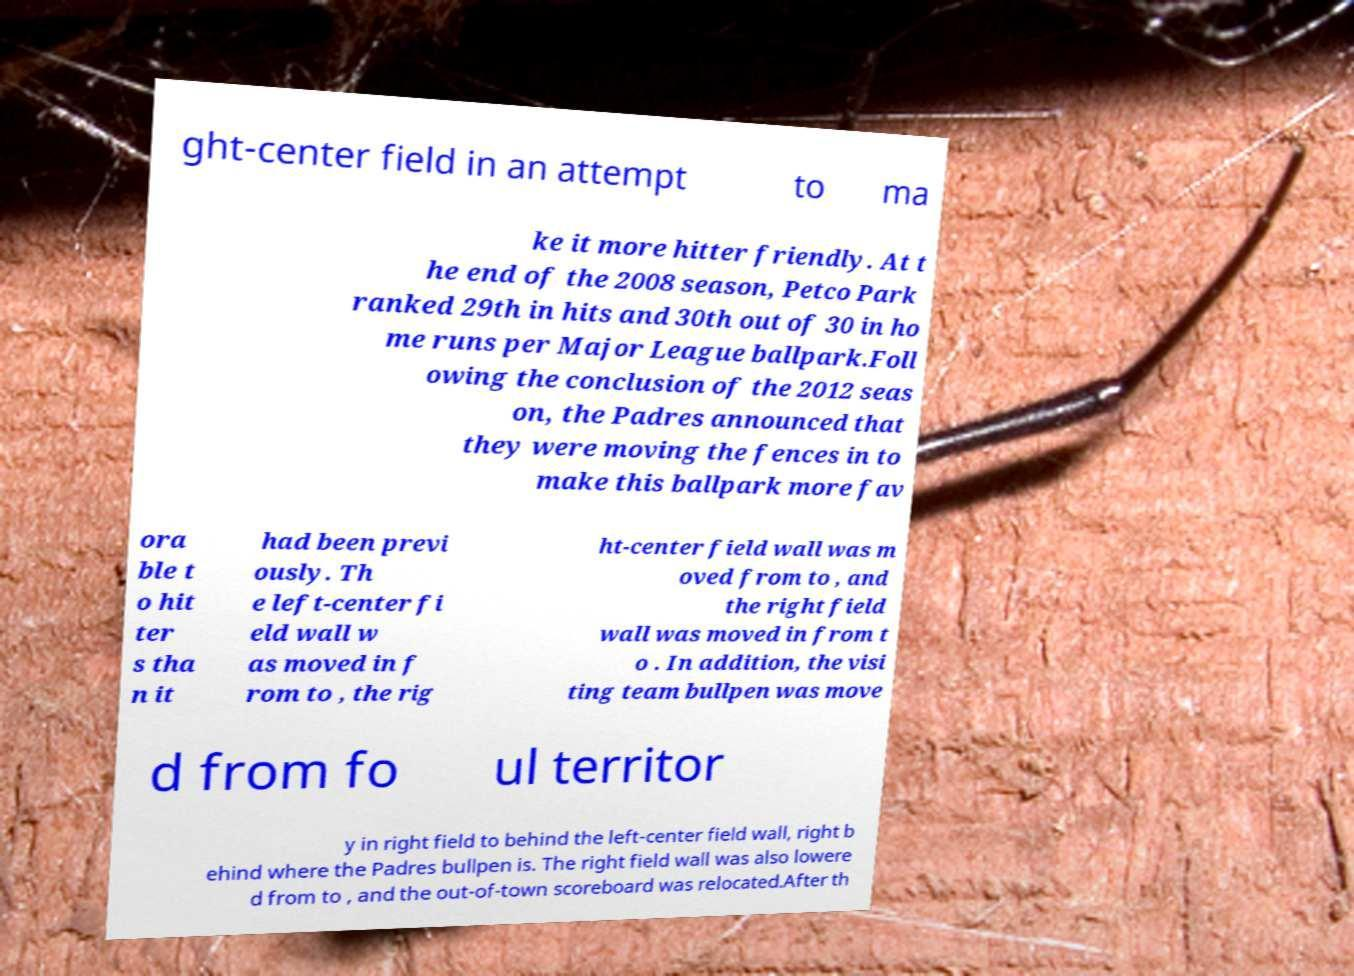Can you read and provide the text displayed in the image?This photo seems to have some interesting text. Can you extract and type it out for me? ght-center field in an attempt to ma ke it more hitter friendly. At t he end of the 2008 season, Petco Park ranked 29th in hits and 30th out of 30 in ho me runs per Major League ballpark.Foll owing the conclusion of the 2012 seas on, the Padres announced that they were moving the fences in to make this ballpark more fav ora ble t o hit ter s tha n it had been previ ously. Th e left-center fi eld wall w as moved in f rom to , the rig ht-center field wall was m oved from to , and the right field wall was moved in from t o . In addition, the visi ting team bullpen was move d from fo ul territor y in right field to behind the left-center field wall, right b ehind where the Padres bullpen is. The right field wall was also lowere d from to , and the out-of-town scoreboard was relocated.After th 